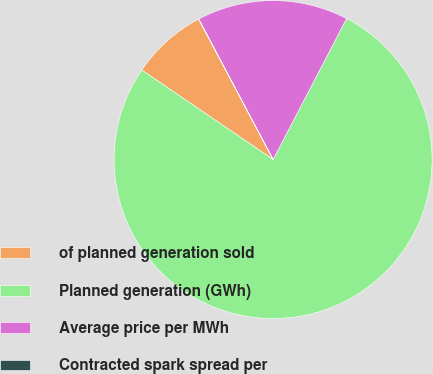Convert chart. <chart><loc_0><loc_0><loc_500><loc_500><pie_chart><fcel>of planned generation sold<fcel>Planned generation (GWh)<fcel>Average price per MWh<fcel>Contracted spark spread per<nl><fcel>7.71%<fcel>76.87%<fcel>15.39%<fcel>0.02%<nl></chart> 